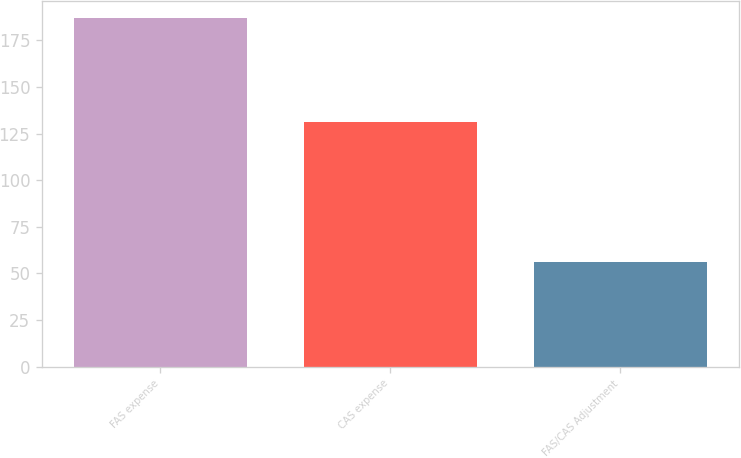Convert chart. <chart><loc_0><loc_0><loc_500><loc_500><bar_chart><fcel>FAS expense<fcel>CAS expense<fcel>FAS/CAS Adjustment<nl><fcel>187<fcel>131<fcel>56<nl></chart> 